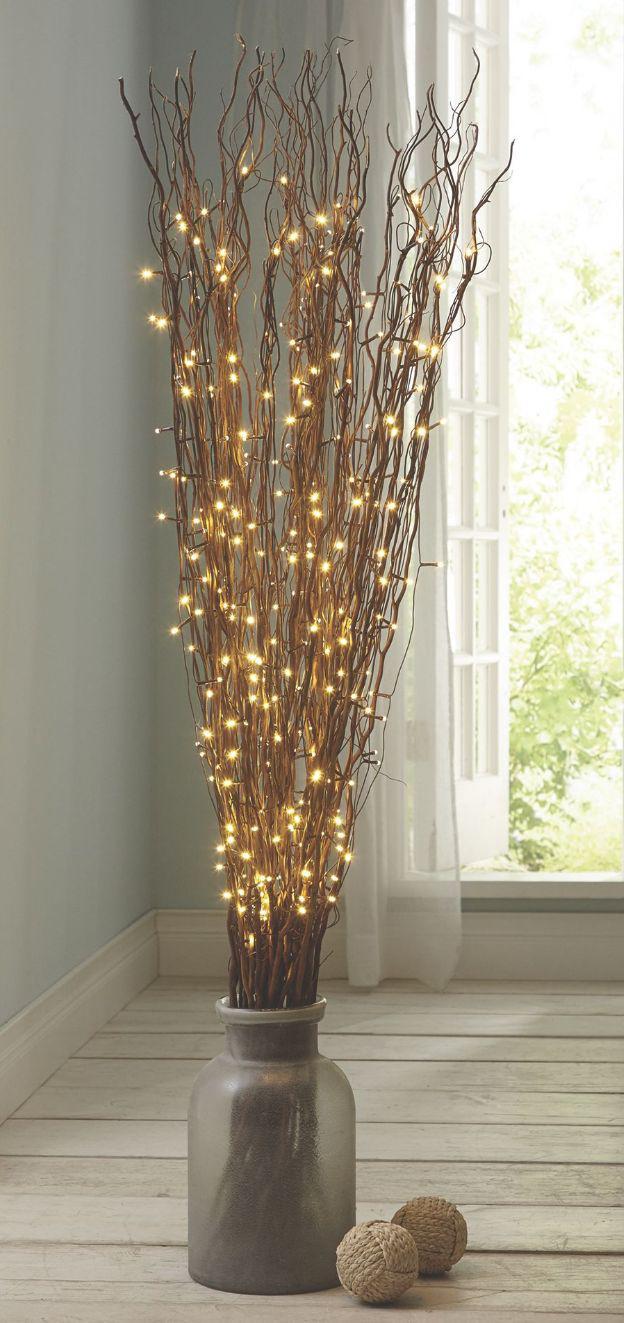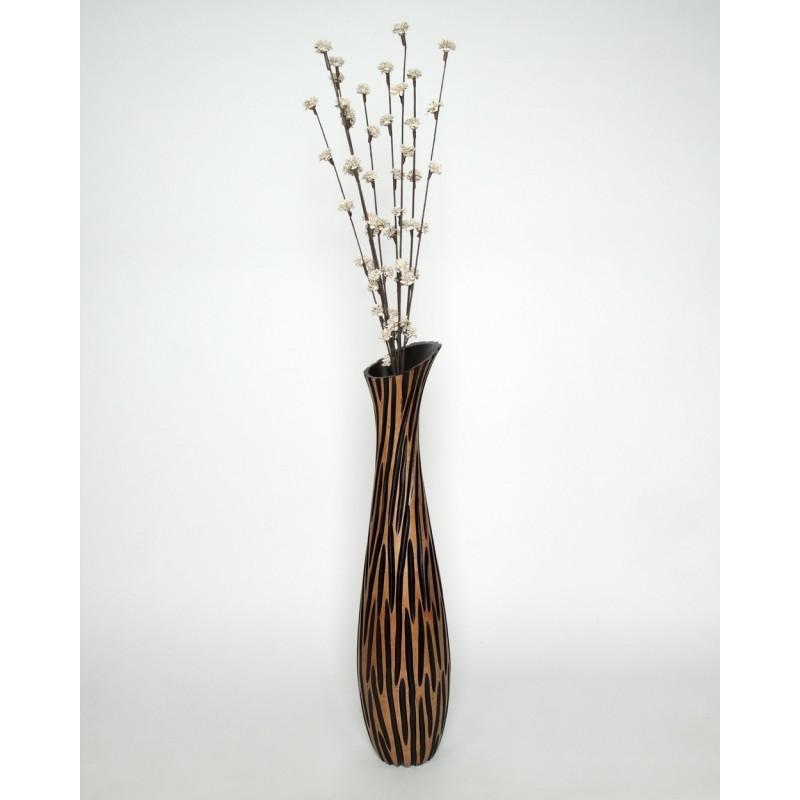The first image is the image on the left, the second image is the image on the right. Assess this claim about the two images: "there is one vase on the right image". Correct or not? Answer yes or no. Yes. 